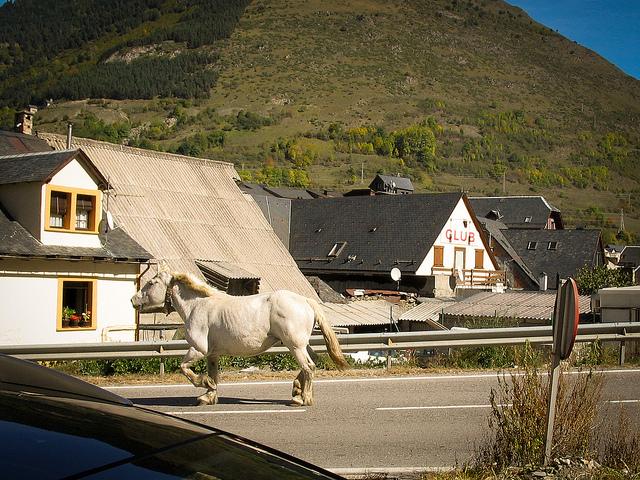What word is placed on the house in the middle?
Short answer required. Club. Which direction is the horse going?
Concise answer only. Left. What color is the trim on the house beside the horse?
Give a very brief answer. Yellow. 